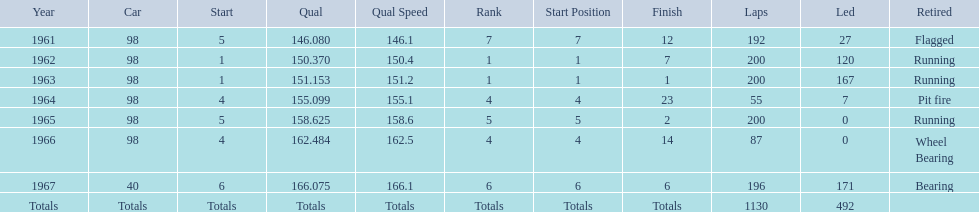In how many indy 500 races, has jones been flagged? 1. 